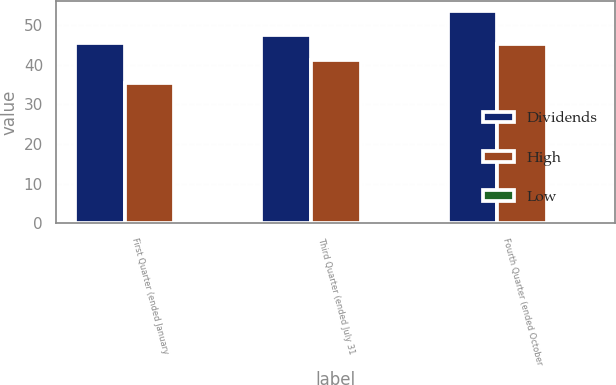Convert chart to OTSL. <chart><loc_0><loc_0><loc_500><loc_500><stacked_bar_chart><ecel><fcel>First Quarter (ended January<fcel>Third Quarter (ended July 31<fcel>Fourth Quarter (ended October<nl><fcel>Dividends<fcel>45.55<fcel>47.47<fcel>53.47<nl><fcel>High<fcel>35.45<fcel>41.24<fcel>45.32<nl><fcel>Low<fcel>0.22<fcel>0.12<fcel>0.12<nl></chart> 